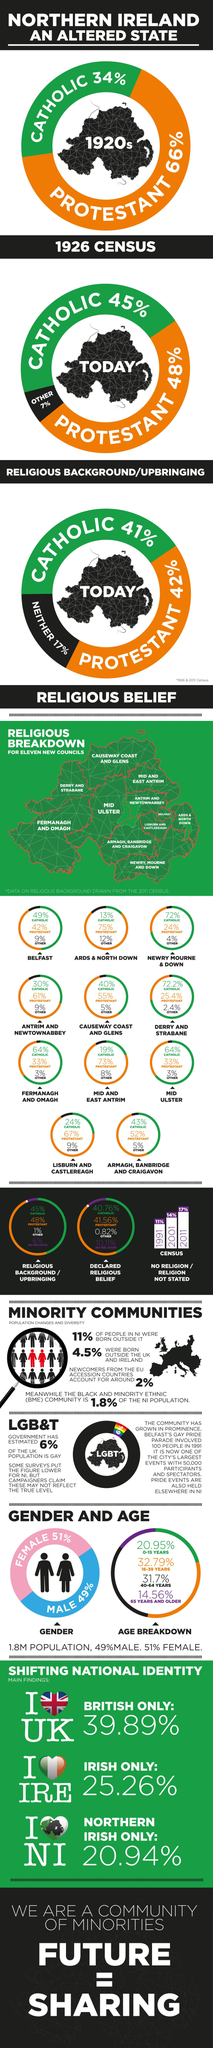Indicate a few pertinent items in this graphic. According to a recent survey, approximately 33% of the population in Mid Ulster identify as Protestant. The leftmost state in Northern Ireland is Fermanagh and Omagh. According to a recent survey, 39.89% of the population of Britain expresses strong feelings of love and patriotism towards their home country. The form of Christianity with the second majority in Belfast is Protestantism. The highest population of Northern Ireland belongs to the age group of 16-39 years. 